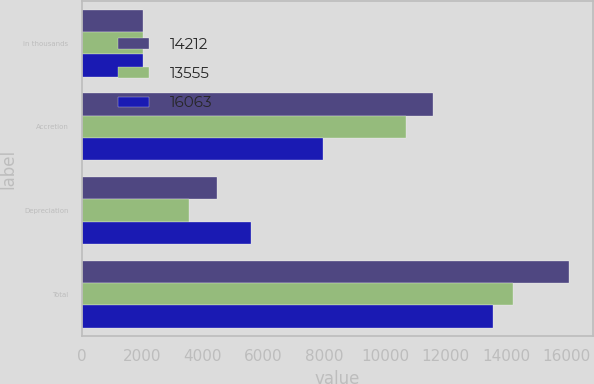Convert chart to OTSL. <chart><loc_0><loc_0><loc_500><loc_500><stacked_bar_chart><ecel><fcel>in thousands<fcel>Accretion<fcel>Depreciation<fcel>Total<nl><fcel>14212<fcel>2014<fcel>11601<fcel>4462<fcel>16063<nl><fcel>13555<fcel>2013<fcel>10685<fcel>3527<fcel>14212<nl><fcel>16063<fcel>2012<fcel>7956<fcel>5599<fcel>13555<nl></chart> 